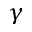<formula> <loc_0><loc_0><loc_500><loc_500>\gamma</formula> 